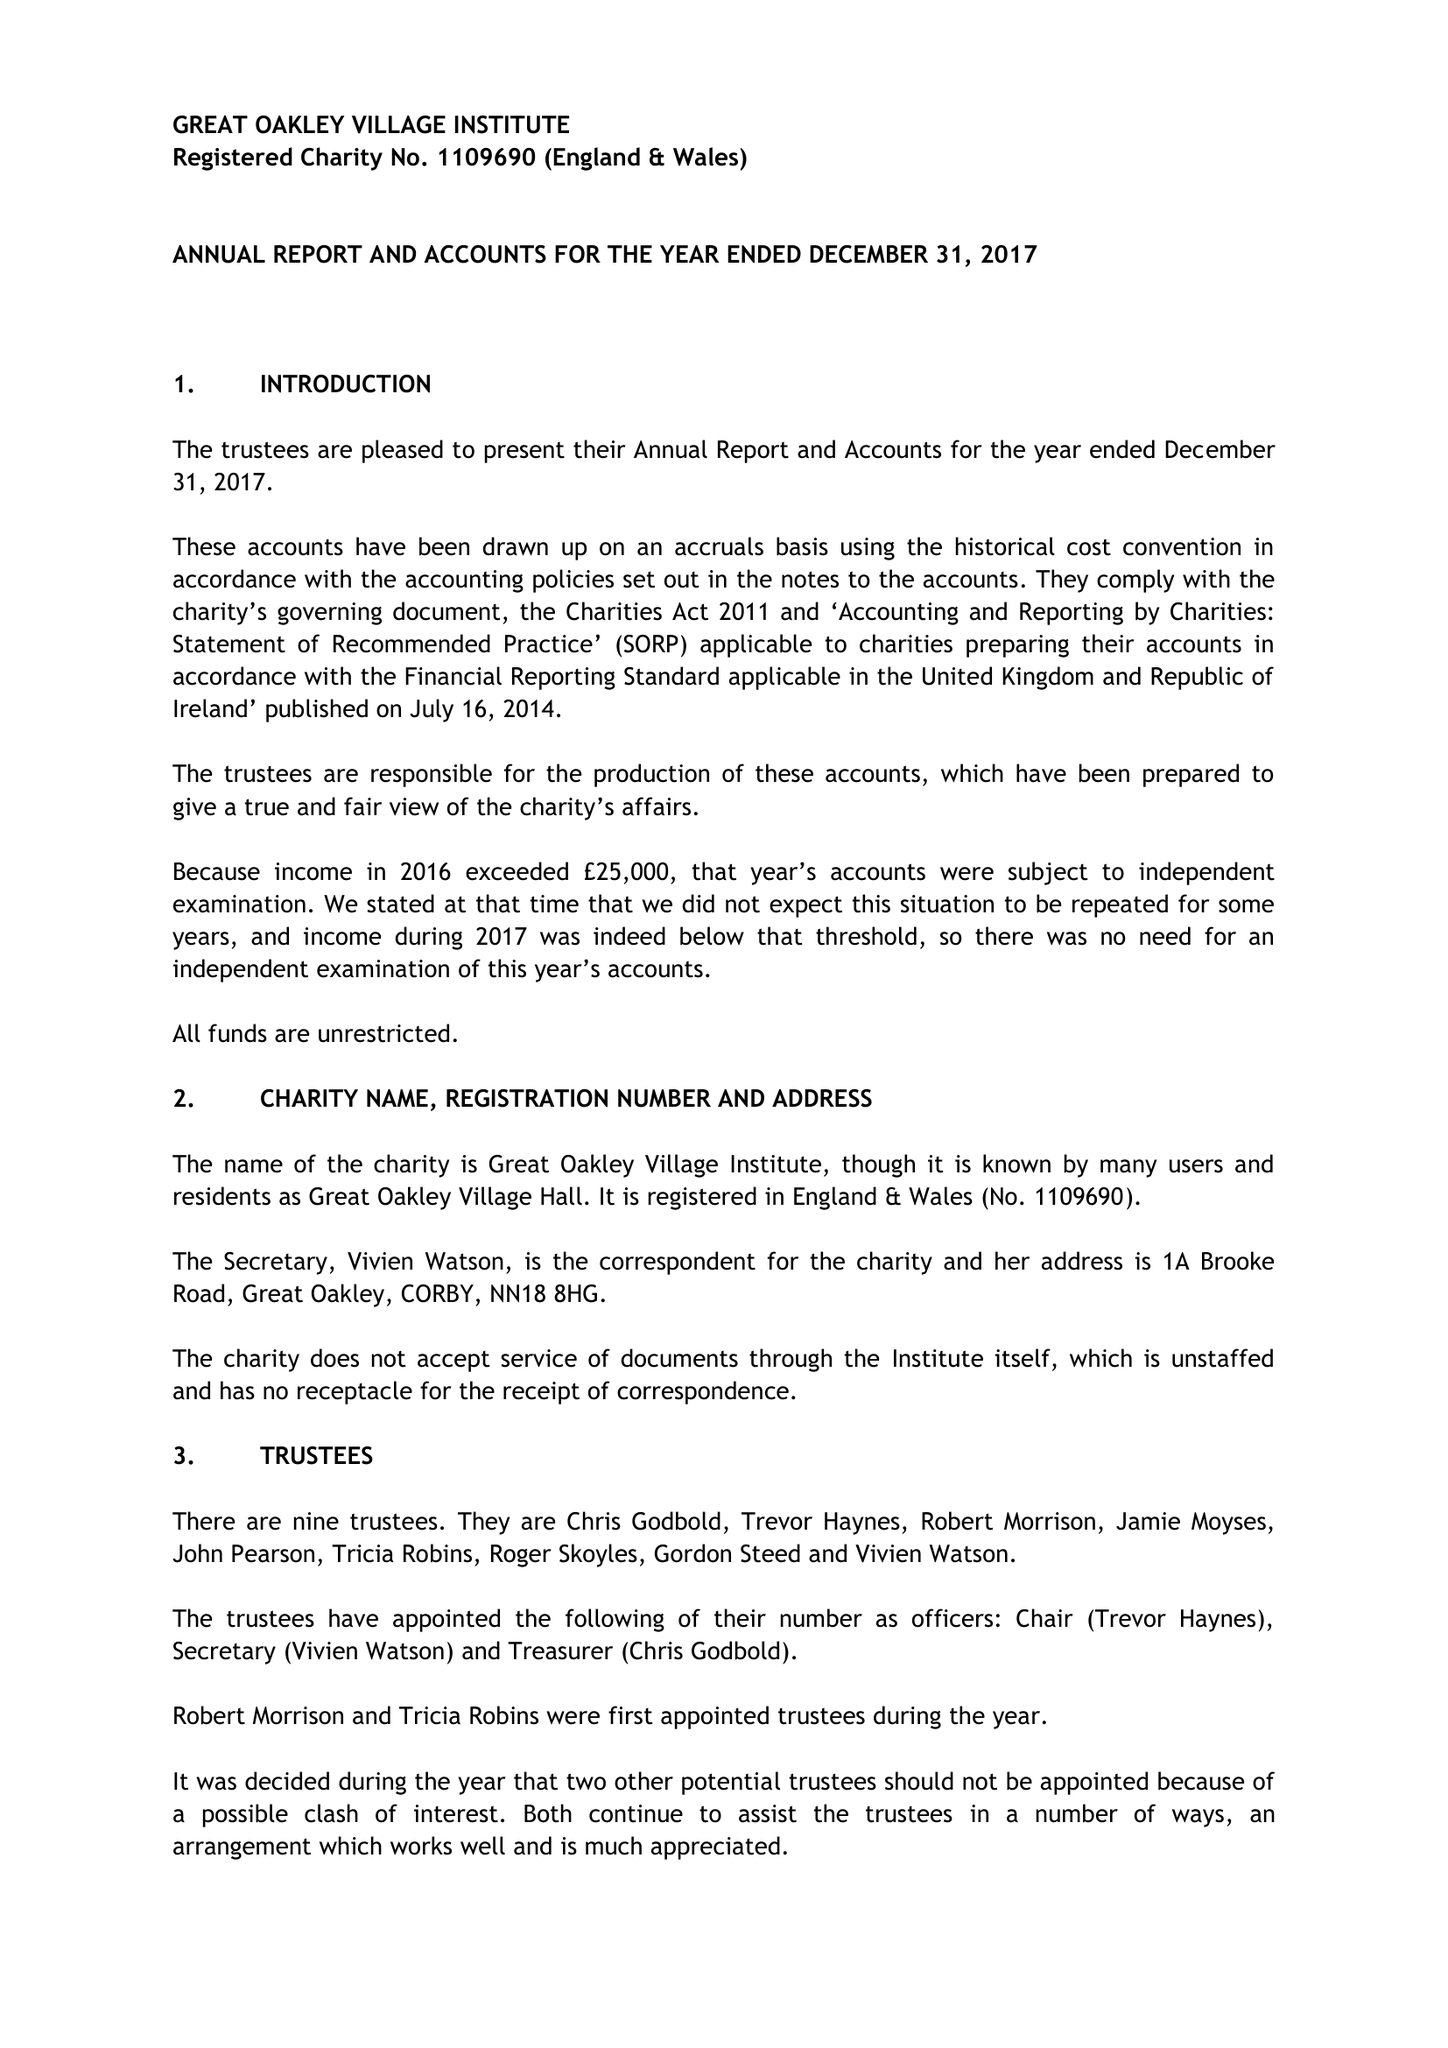What is the value for the charity_name?
Answer the question using a single word or phrase. Great Oakley Village Institute 